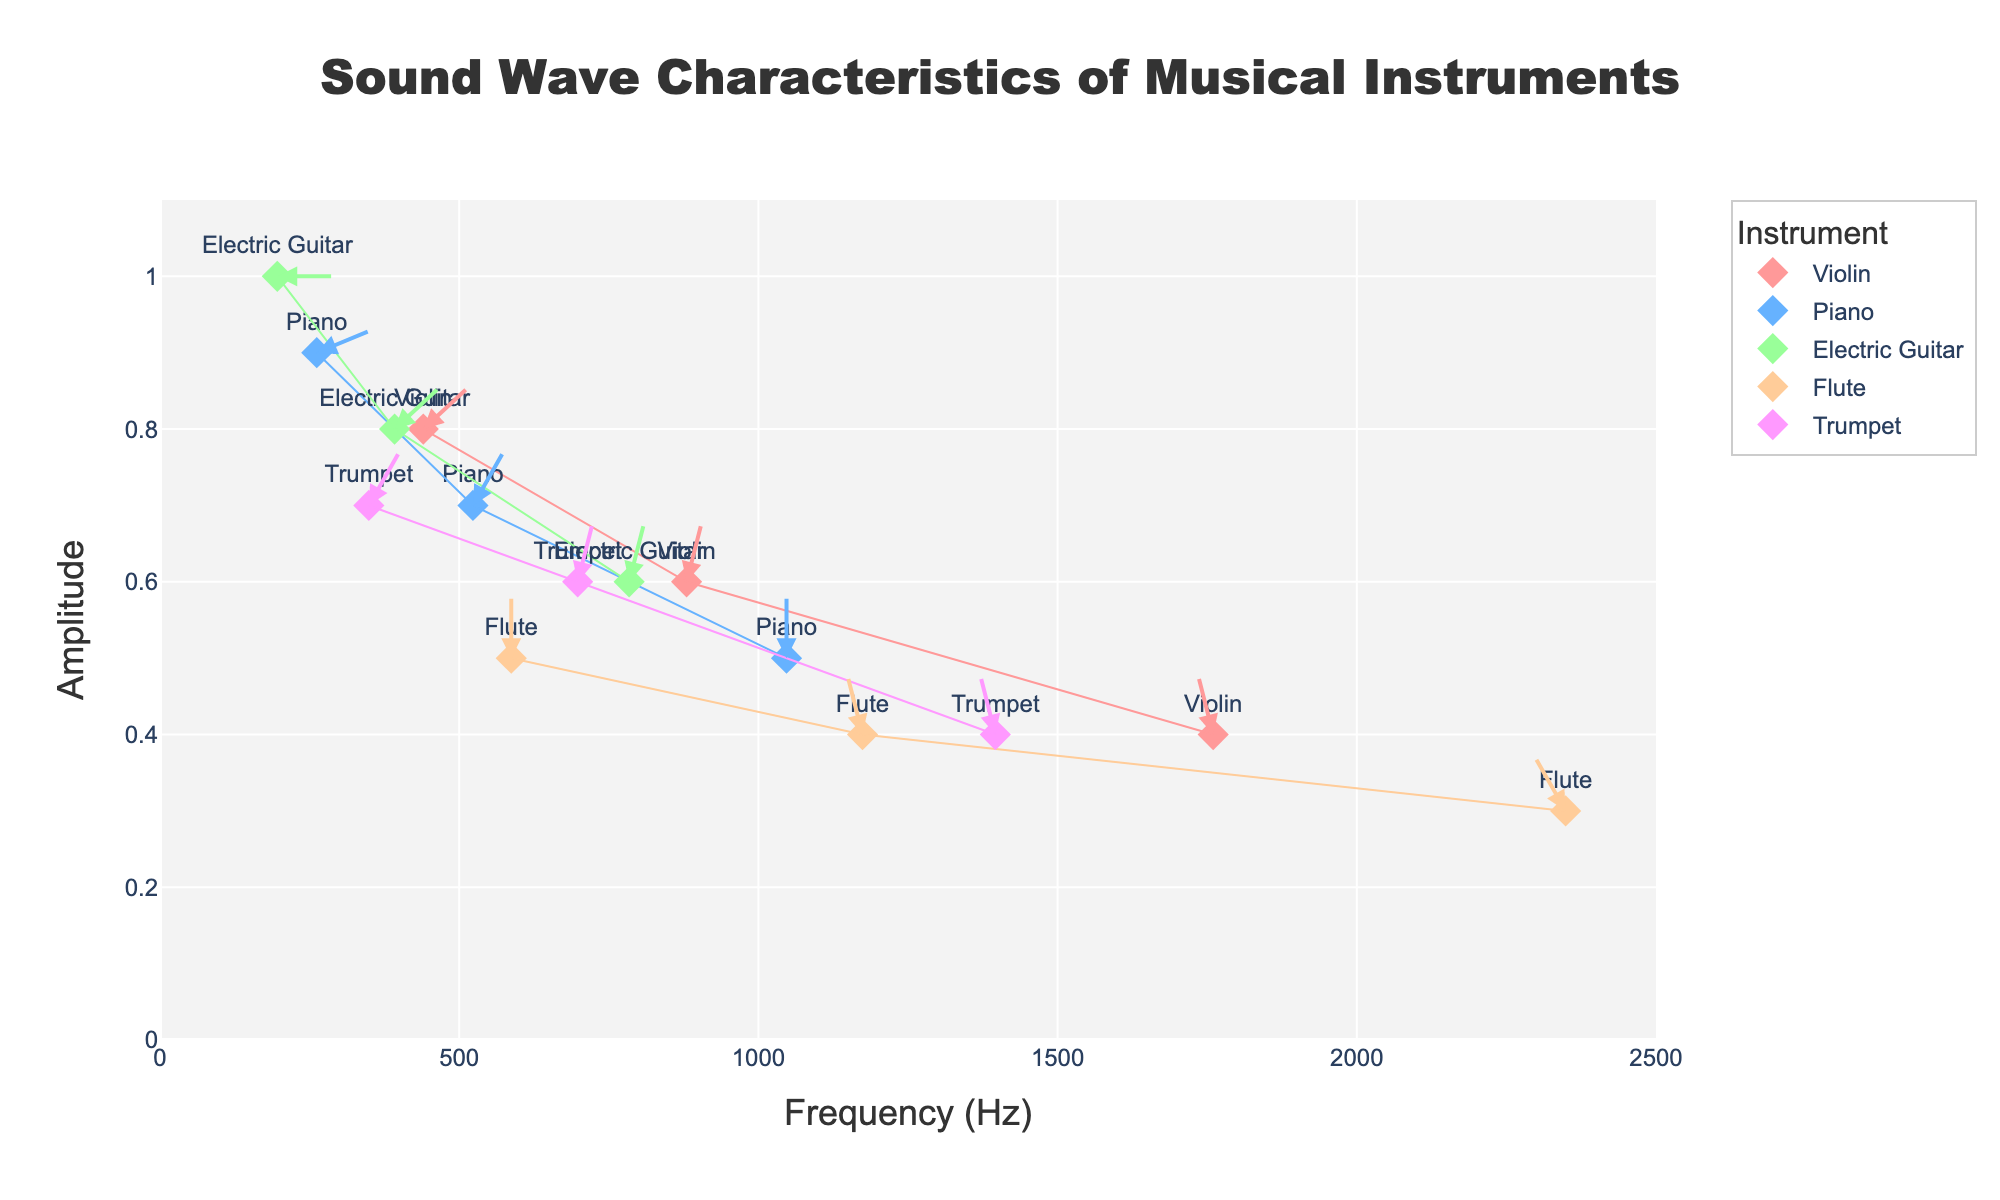How many different instruments are represented in the plot? By looking at the legend or the markers corresponding to different instruments in the plot, you can count the distinct instruments.
Answer: 5 What is the highest amplitude recorded for the Electric Guitar? Locate the points corresponding to the Electric Guitar on the amplitude axis. The highest amplitude for the Electric Guitar is where the amplitude is 1.0.
Answer: 1.0 Which instrument has the highest frequency point on the plot? By looking at the frequency axis, identify the instrument with the point farthest to the right. The Flute has the highest frequency point at 2349 Hz.
Answer: Flute What is the difference in amplitude between Violin and Piano at their closest frequency points? Locate the closest frequency points for Violin (440 Hz) and Piano (523 Hz). The amplitudes are 0.8 for Violin and 0.7 for Piano. The difference is 0.8 - 0.7 = 0.1.
Answer: 0.1 Which instrument shows the shortest arrow length in the plot? Arrows indicate phase-related properties. The shortest arrow belongs to the Electric Guitar with a phase of 0.0, meaning the arrow length is minimal.
Answer: Electric Guitar What is the average frequency of the data points for the Trumpet? Add the frequencies of Trump's data points: 349 Hz, 698 Hz, and 1396 Hz. Divide by the number of data points (3). (349 + 698 + 1396) / 3 = 814.33 Hz.
Answer: 814.33 Which instrument's datapoints show the most consistent amplitude values? By visually inspecting the vertical spread of the points for each instrument, the Violin shows the most consistent amplitudes with values of 0.8, 0.6, and 0.4.
Answer: Violin At which frequency does the Violin have its lowest amplitude? Look at the data points for the Violin. The lowest amplitude (0.4) occurs at the frequency 1760 Hz.
Answer: 1760 Compare the average phase values of the Piano and Flute. Which one is higher? The Piano has phase values of 0.1, 0.3, 0.5. The average is (0.1 + 0.3 + 0.5) / 3 = 0.3. The Flute has phase values of 0.5, 0.6, 0.7. The average is (0.5 + 0.6 + 0.7) / 3 = 0.6. Flute's average phase is higher.
Answer: Flute 